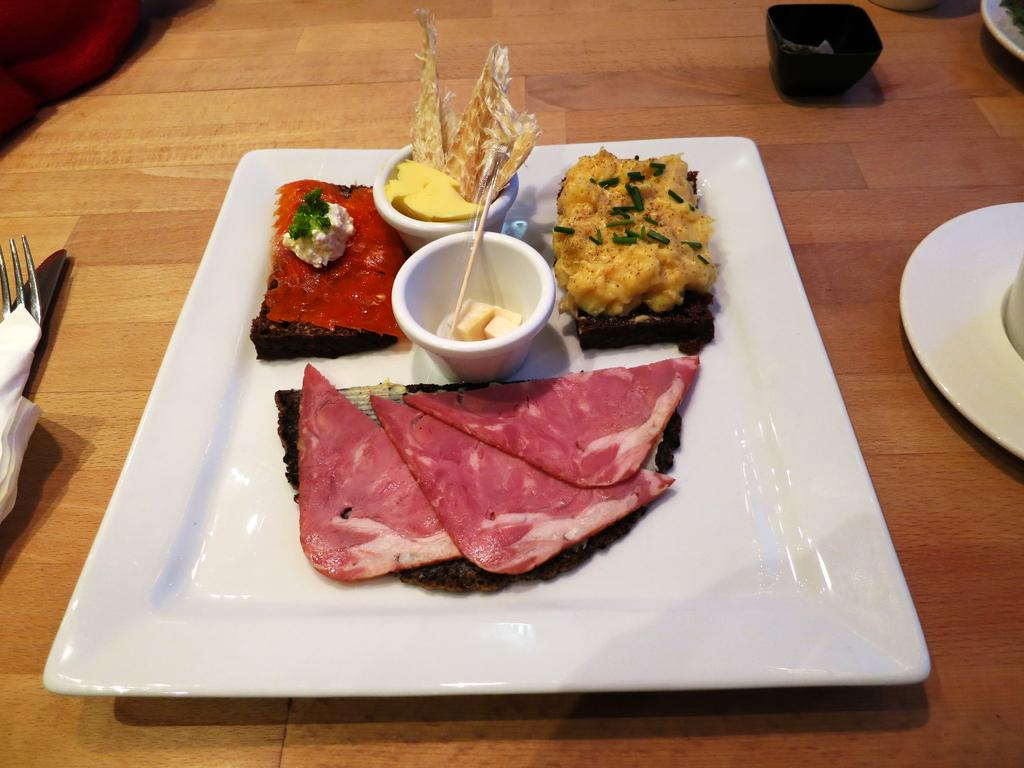What is present in the tray in the image? There are food items in a tray in the image. What can be seen on the table in the image? There are plates, spoons, and tissues on the table in the image. How many muscles can be seen in the image? There are no muscles visible in the image. Are there any jellyfish present in the image? There are no jellyfish present in the image. 